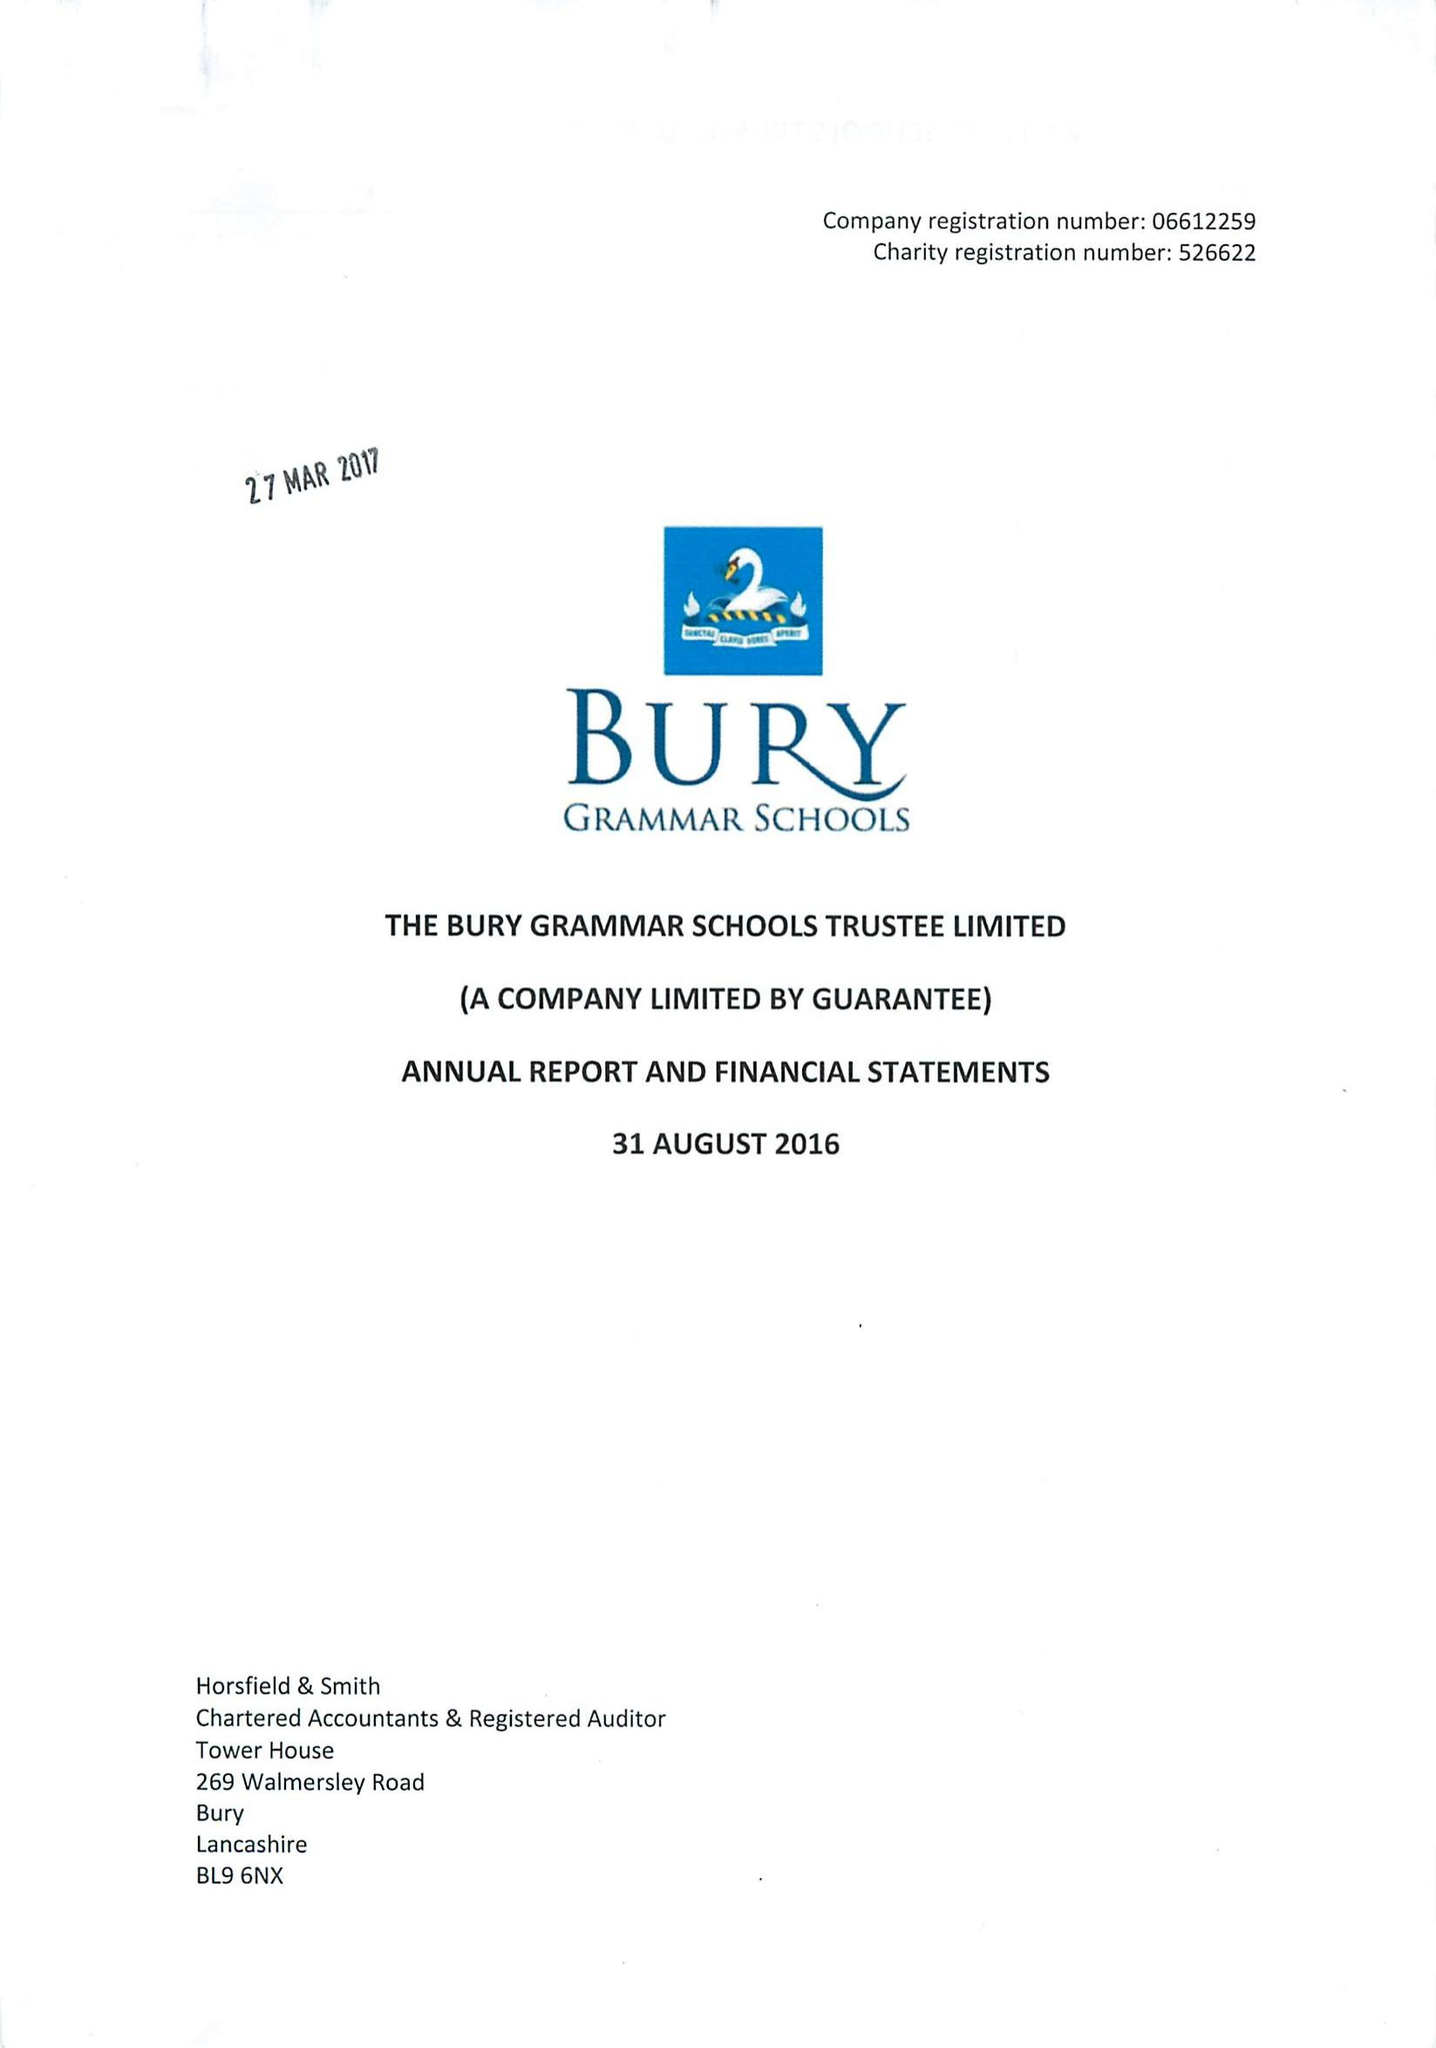What is the value for the address__post_town?
Answer the question using a single word or phrase. BURY 